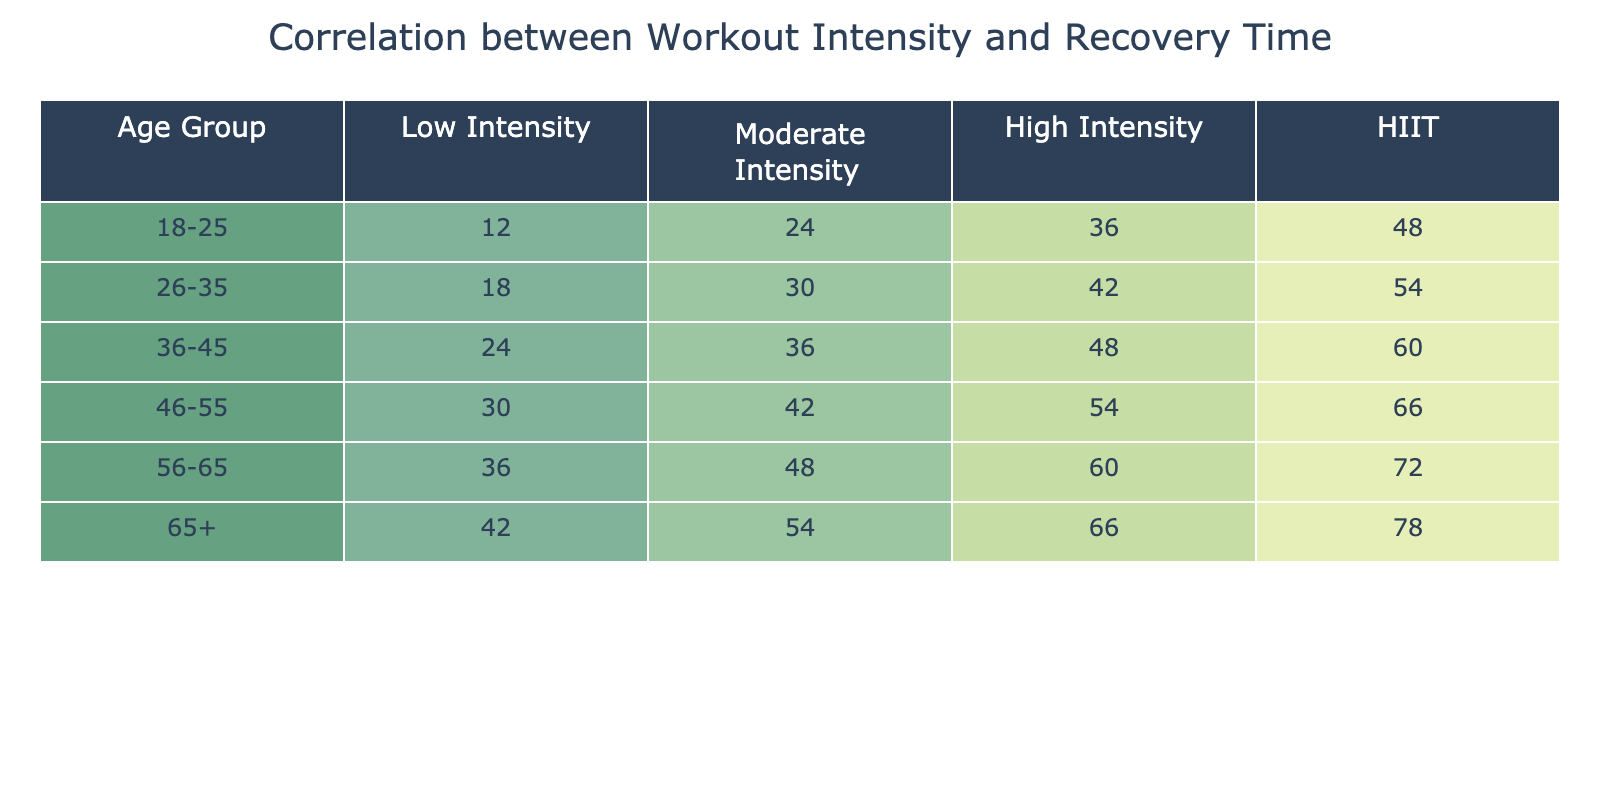What is the recovery time for the "High Intensity" workout in the age group 36-45? The table shows that for the age group 36-45, the recovery time for High Intensity is listed as 48.
Answer: 48 Which age group has the highest recovery time for "HIIT"? By looking at the HIIT column, the value for the age group 65+ is 78, which is the highest among all groups.
Answer: 65+ What is the difference in recovery time between Low Intensity and Moderate Intensity for the age group 46-55? For the age group 46-55, the recovery time for Low Intensity is 30 and for Moderate Intensity is 42. The difference is calculated as 42 - 30 = 12.
Answer: 12 What is the average recovery time for the "Moderate Intensity" workout across all age groups? To find the average for Moderate Intensity, sum up the values: 24 + 30 + 36 + 42 + 48 + 54 = 234. Then divide by the number of age groups, which is 6: 234 / 6 = 39.
Answer: 39 Is the recovery time for "Low Intensity" in the age group 18-25 greater than that for "Moderate Intensity" in the age group 56-65? The Low Intensity recovery time for 18-25 is 12, while for Moderate Intensity in 56-65 it is 48. Since 12 is less than 48, the statement is false.
Answer: False If a person aged 26-35 chooses "High Intensity" workouts, what will be their recovery time? According to the table, the recovery time for High Intensity workouts in the age group 26-35 is 42.
Answer: 42 What is the total recovery time for "HIIT" workouts across the age groups 36-45 and 46-55? Add the HIIT values for age groups 36-45 and 46-55: 60 + 66 = 126.
Answer: 126 How does the "Low Intensity" recovery time for the age group 65+ compare to that of 56-65? For 65+, the recovery time is 42, and for 56-65, it is 36. Since 42 is greater than 36, the comparison shows that the recovery time for 65+ is higher.
Answer: Higher What is the recovery time for "Moderate Intensity" workouts in the youngest age group? The recovery time for Moderate Intensity in the age group 18-25 is 24 according to the table.
Answer: 24 What are the values for recovery time in the "High Intensity" category across all age groups? The values for High Intensity from the table are 36, 42, 48, 54, 60, and 66 for age groups 18-25, 26-35, 36-45, 46-55, 56-65, and 65+, respectively.
Answer: 36, 42, 48, 54, 60, 66 In which workout intensity category does the 56-65 age group have the greatest recovery time? By comparing the values, we see that in the HIIT category, the recovery time is 72, which is the greatest for the age group 56-65.
Answer: HIIT 